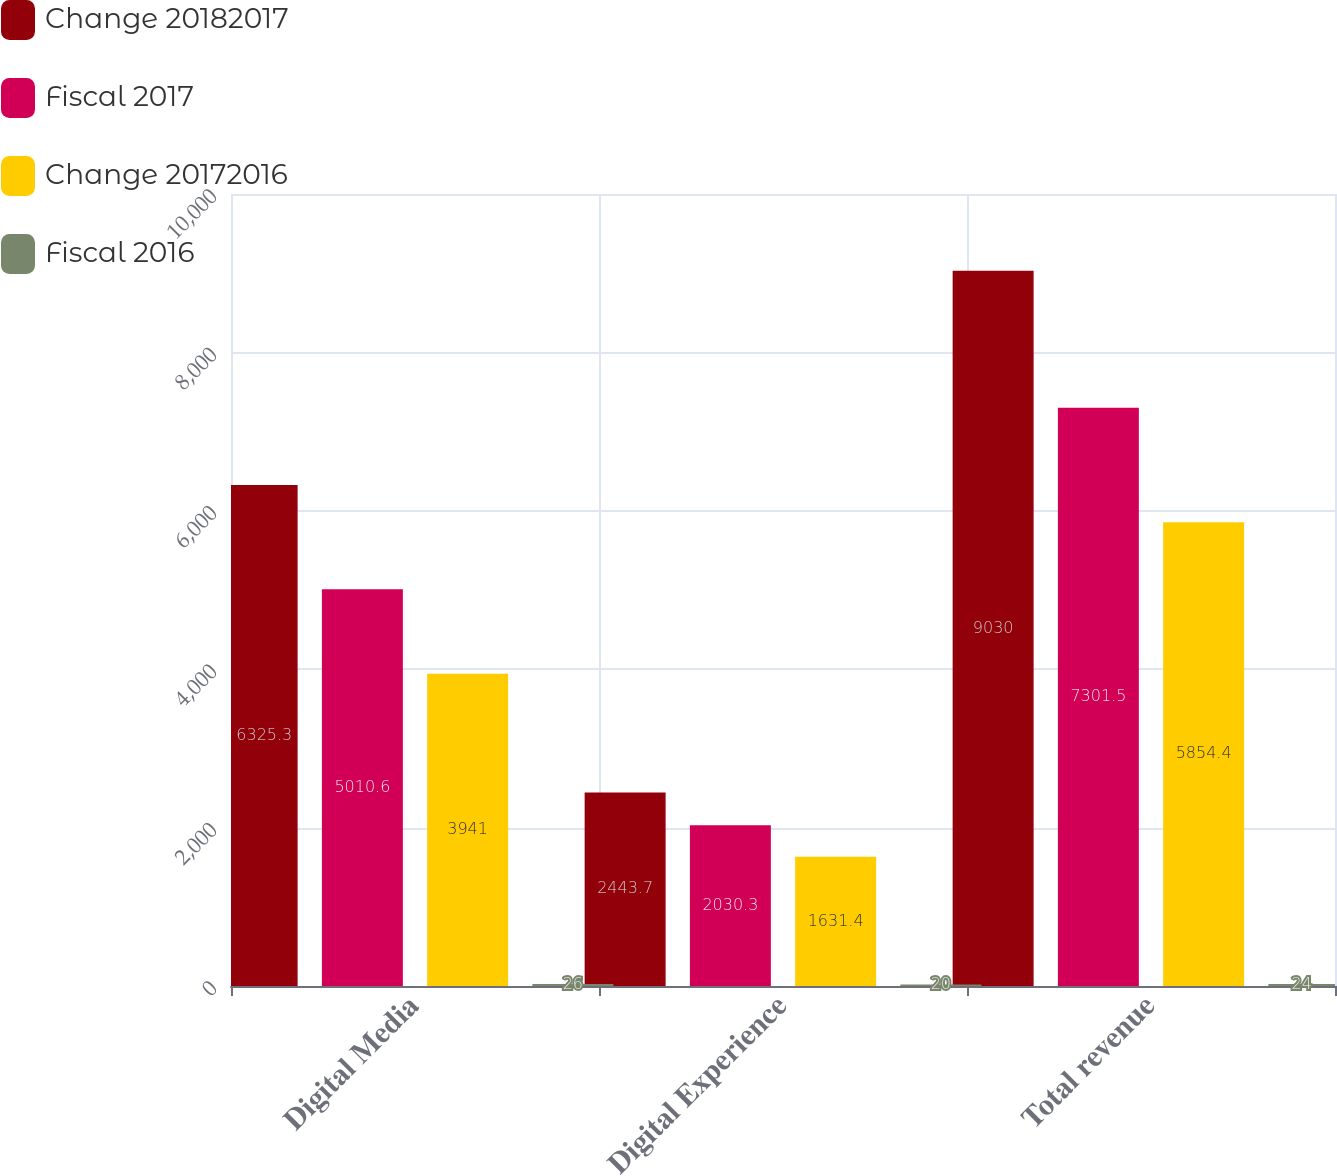<chart> <loc_0><loc_0><loc_500><loc_500><stacked_bar_chart><ecel><fcel>Digital Media<fcel>Digital Experience<fcel>Total revenue<nl><fcel>Change 20182017<fcel>6325.3<fcel>2443.7<fcel>9030<nl><fcel>Fiscal 2017<fcel>5010.6<fcel>2030.3<fcel>7301.5<nl><fcel>Change 20172016<fcel>3941<fcel>1631.4<fcel>5854.4<nl><fcel>Fiscal 2016<fcel>26<fcel>20<fcel>24<nl></chart> 